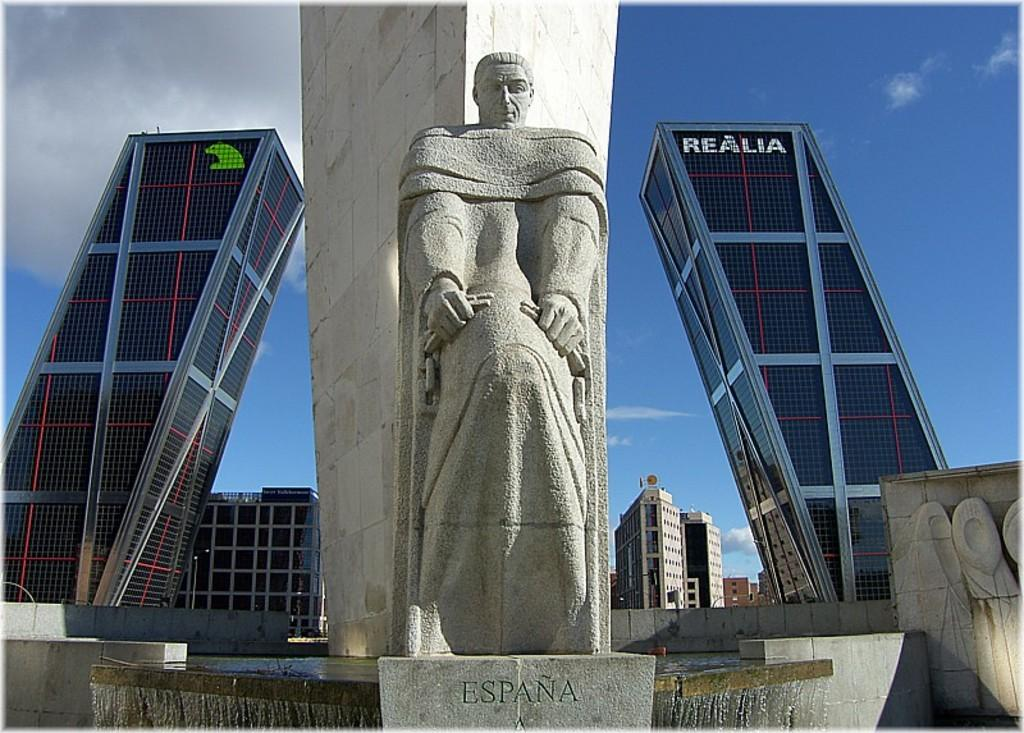What is the main subject in the image? There is a statue in the image. What material is the statue made of? The statue is made of rock. What can be seen in the background of the image? There are buildings in the background of the image. What is visible at the top of the image? The sky is visible at the top of the image. What is the condition of the sky in the image? The sky has clouds in the image. How many screws are visible on the statue in the image? There are no screws present on the statue in the image, as it is made of rock and not a mechanical object. 